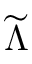Convert formula to latex. <formula><loc_0><loc_0><loc_500><loc_500>\widetilde { \Lambda }</formula> 